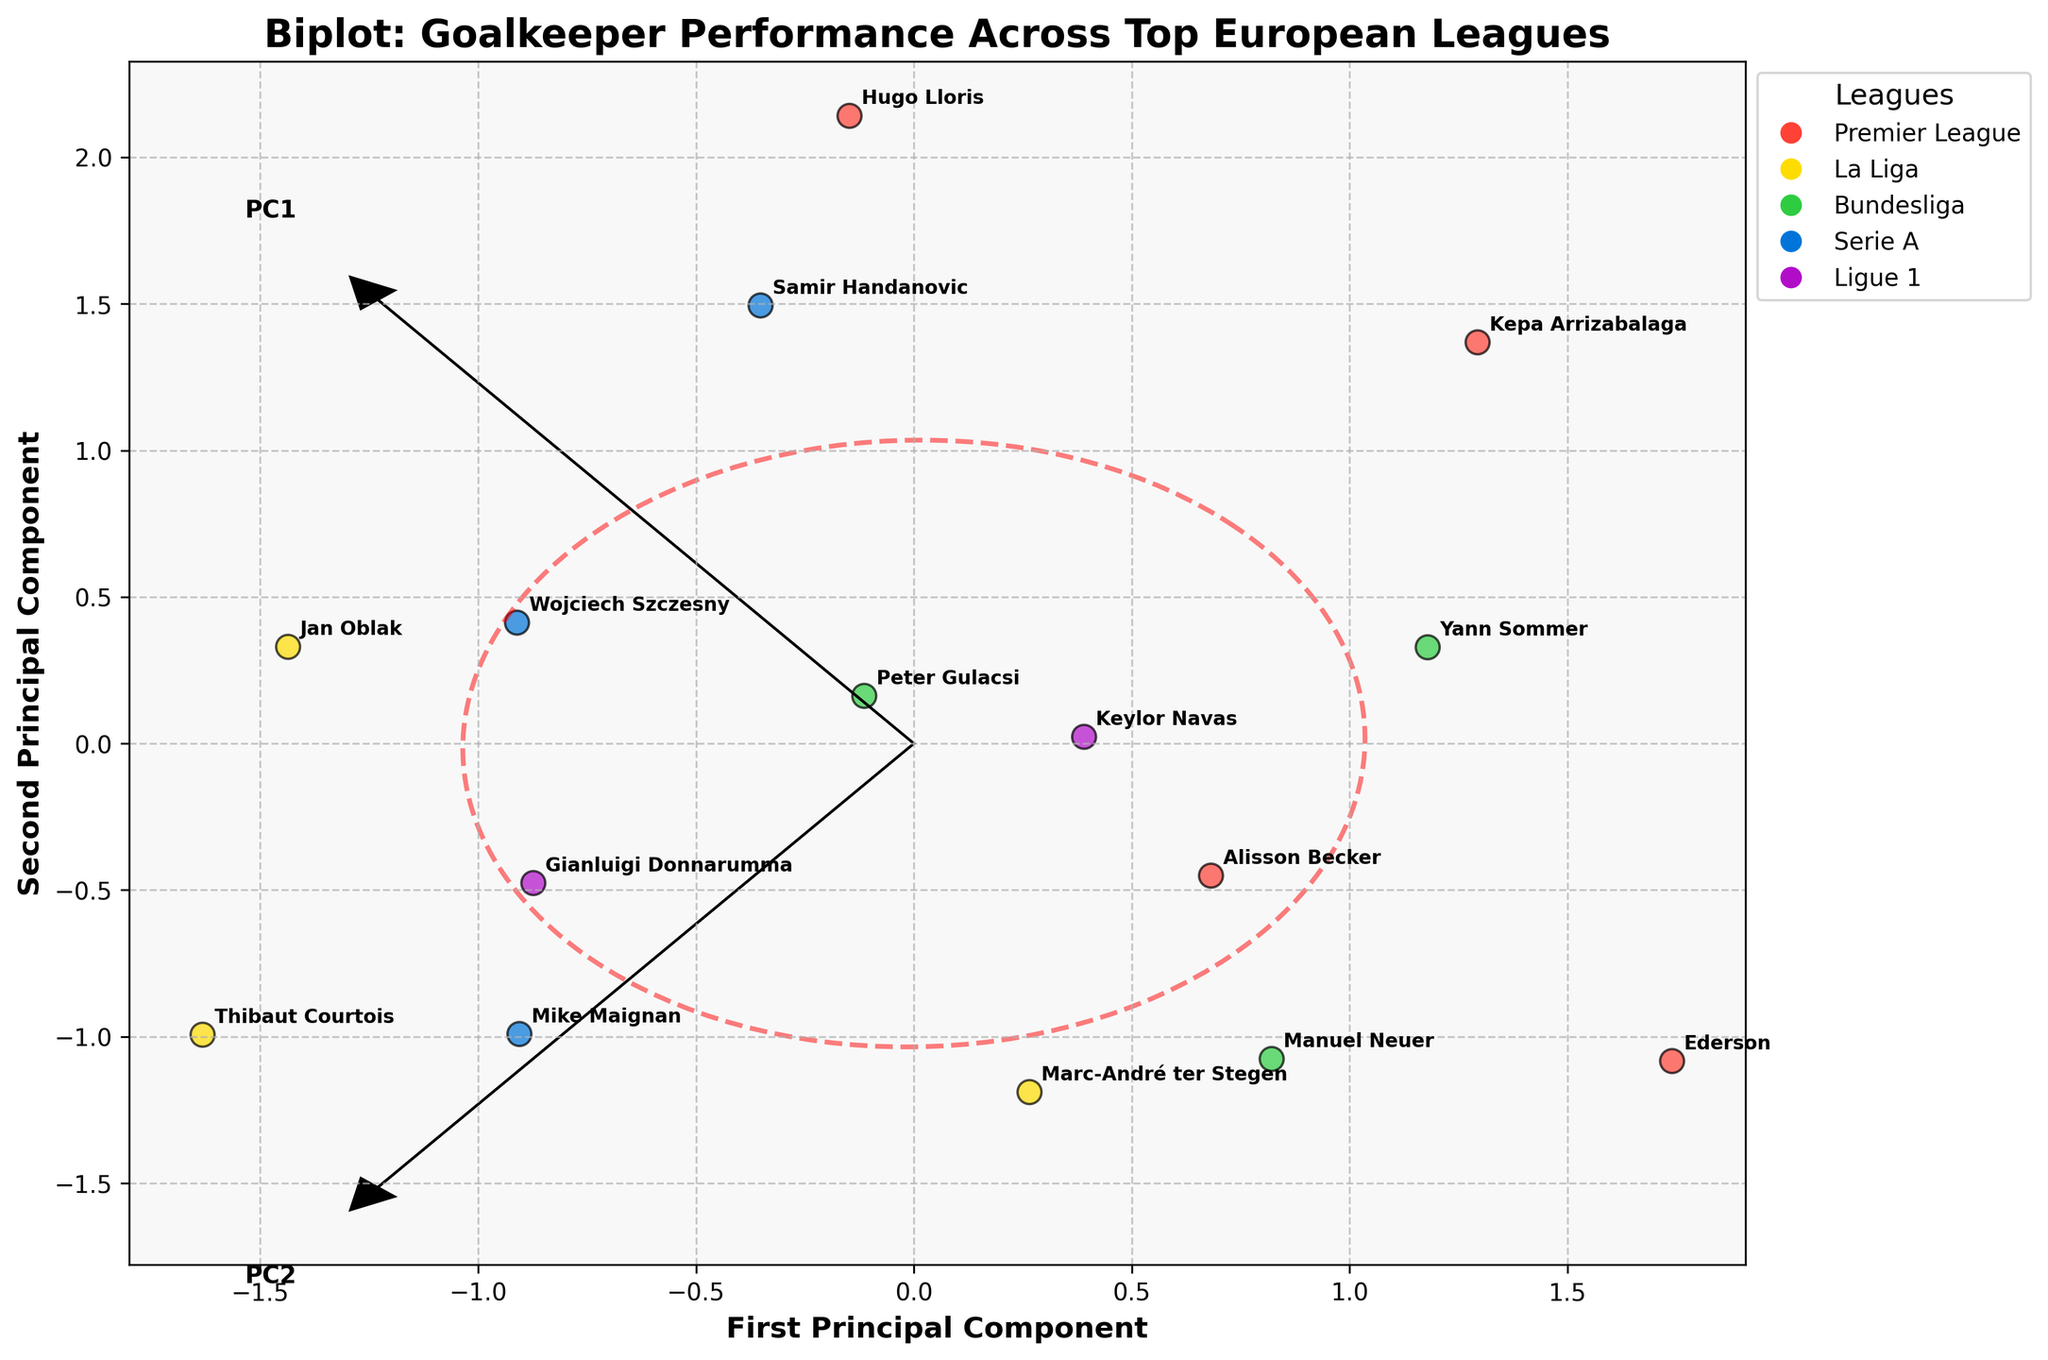Who has the highest save percentage? The figure indicates the position of each goalkeeper, where the one closest to the top of the first principal component axis typically indicates higher save percentages. Upon examining, Thibaut Courtois is positioned the highest.
Answer: Thibaut Courtois Which league is Gianluigi Donnarumma representing? Each data point is color-coded according to the league. Gianluigi Donnarumma is positioned and his color corresponds to the color used for Ligue 1.
Answer: Ligue 1 What are the two principal components used in the biplot? The x-axis and y-axis represent the first and second principal components, respectively, as indicated by the labeled arrows labeled PC1 and PC2.
Answer: First Principal Component and Second Principal Component Which goalkeeper has the highest distribution accuracy? The goalkeepers closest to the far right of the first principal component axis typically indicate higher distribution accuracy. Manuel Neuer seems to be positioned furthest to the right.
Answer: Manuel Neuer How many goalkeepers are from Serie A? Examining the legend and the scatter plot, identifying the points associated with Serie A based on color coding, reveals four goalkeepers from Serie A: Mike Maignan, Wojciech Szczesny, Samir Handanovic.
Answer: Four Which goalkeepers from the Premier League have distribution accuracies higher than 85%? Examining the Premier League points (red color) in the scatter plot and checking those positioned farthest to the right indicates four goalkeepers: Alisson Becker, Ederson, and Kepa Arrizabalaga.
Answer: Alisson Becker, Ederson, Kepa Arrizabalaga Compare the save percentages of Jan Oblak and Marc-André ter Stegen. Who has a higher value? By examining their positions relative to the first principal component in the scatter plot, Jan Oblak appears higher than Marc-André ter Stegen.
Answer: Jan Oblak Which league has the most goalkeepers in the top right quadrant? By examining the scatter plot and identifying the points in the top right quadrant based on color and labels, the Premier League has multiple points in that quadrant.
Answer: Premier League 